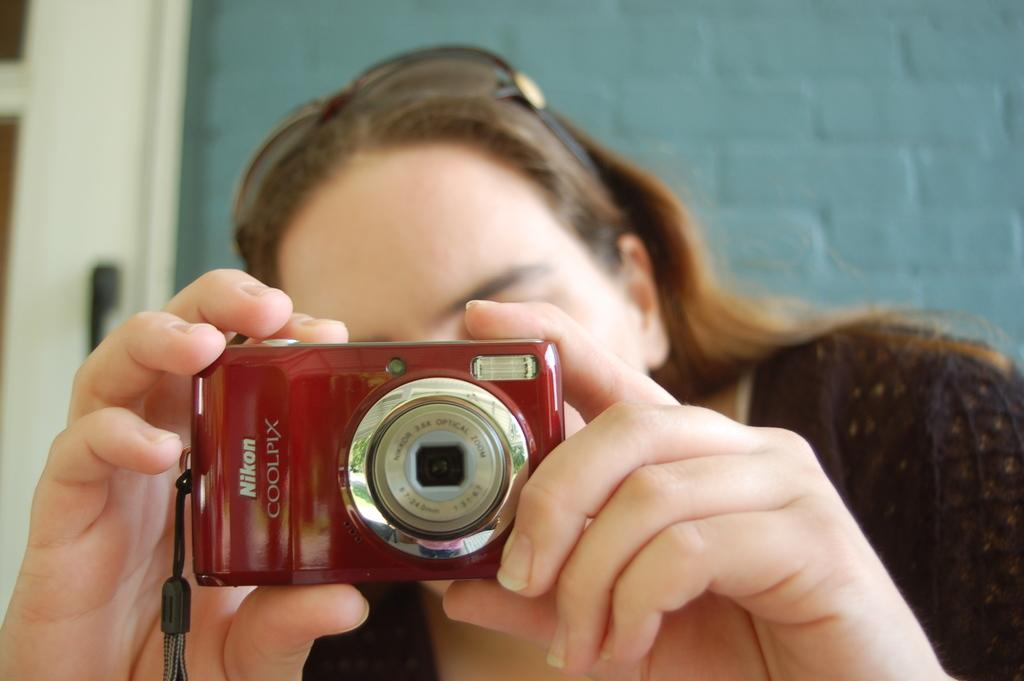What is the main subject of the image? There is a person in the image. What is the person holding in their hands? The person is holding a camera in their hands. What can be seen in the background of the image? There are walls visible in the background of the image. How many letters are on the bed in the image? There is no bed or letters present in the image. What type of aunt can be seen in the image? There is no aunt present in the image. 